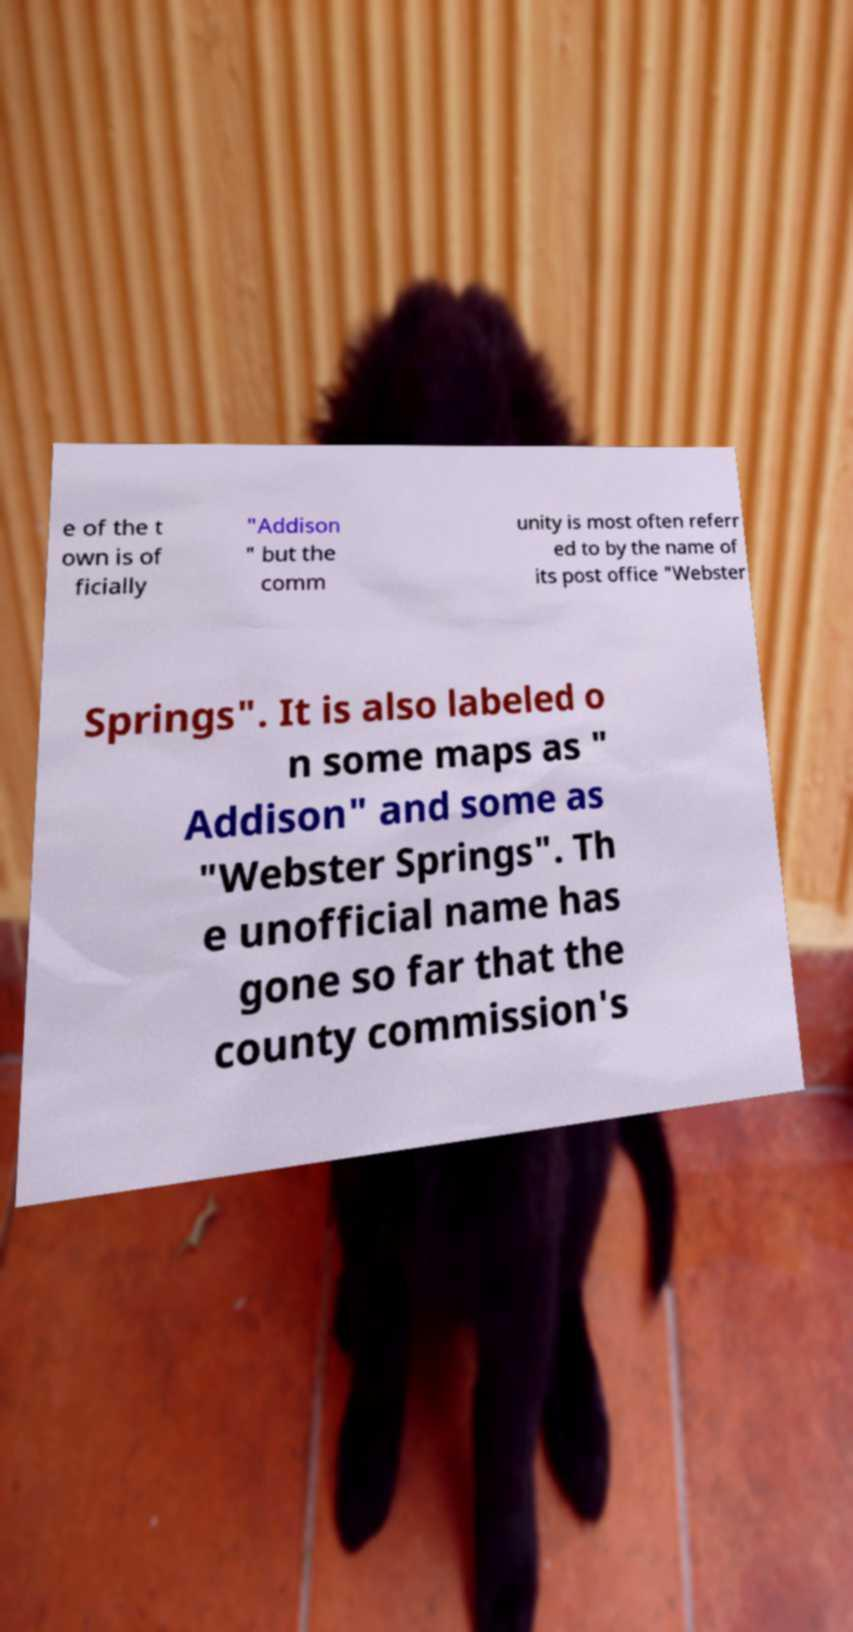Could you assist in decoding the text presented in this image and type it out clearly? e of the t own is of ficially "Addison " but the comm unity is most often referr ed to by the name of its post office "Webster Springs". It is also labeled o n some maps as " Addison" and some as "Webster Springs". Th e unofficial name has gone so far that the county commission's 